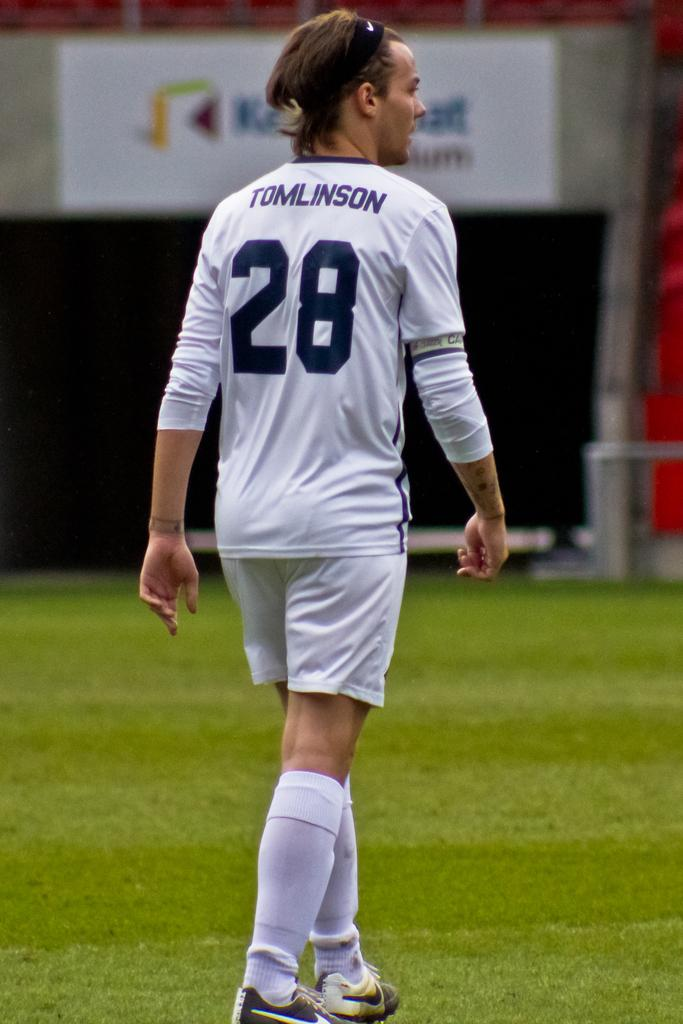<image>
Offer a succinct explanation of the picture presented. A sportsperson with the number 28 on their shirt. 